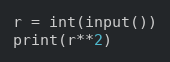<code> <loc_0><loc_0><loc_500><loc_500><_Python_>r = int(input())
print(r**2)
</code> 